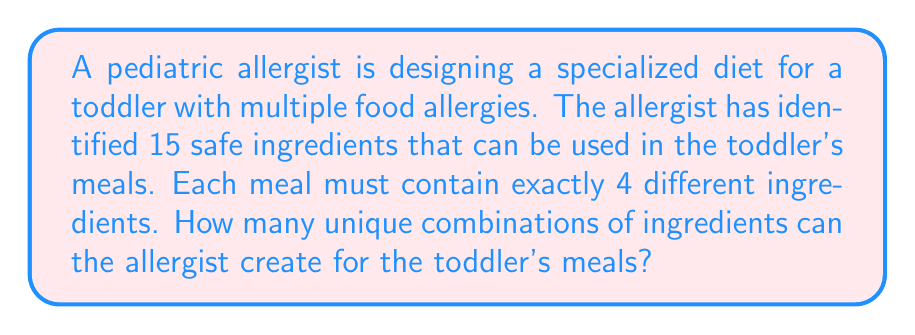Provide a solution to this math problem. To solve this problem, we need to use the combination formula from discrete mathematics. We are selecting 4 ingredients from a total of 15 available ingredients, where the order of selection doesn't matter (since we're just interested in the combination of ingredients, not their arrangement in the meal).

The formula for combinations is:

$$ C(n,r) = \frac{n!}{r!(n-r)!} $$

Where:
$n$ is the total number of items to choose from (in this case, 15 ingredients)
$r$ is the number of items being chosen (in this case, 4 ingredients)

Let's substitute these values into our formula:

$$ C(15,4) = \frac{15!}{4!(15-4)!} = \frac{15!}{4!11!} $$

Now, let's calculate this step-by-step:

1) $15! = 1,307,674,368,000$
2) $4! = 24$
3) $11! = 39,916,800$

Substituting these values:

$$ \frac{1,307,674,368,000}{24 \times 39,916,800} $$

$$ = \frac{1,307,674,368,000}{957,993,600} $$

$$ = 1,365 $$

Therefore, the allergist can create 1,365 unique combinations of 4 ingredients from the 15 safe ingredients.
Answer: 1,365 unique combinations 